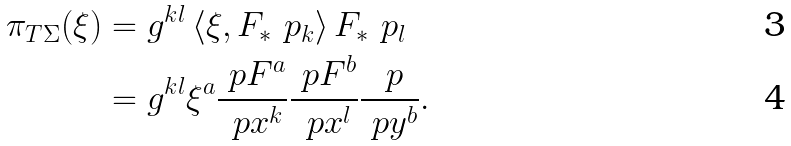<formula> <loc_0><loc_0><loc_500><loc_500>\pi _ { T \Sigma } ( \xi ) & = g ^ { k l } \left \langle \xi , F _ { * } \ p _ { k } \right \rangle F _ { * } \ p _ { l } \\ & = g ^ { k l } \xi ^ { a } \frac { \ p F ^ { a } } { \ p x ^ { k } } \frac { \ p F ^ { b } } { \ p x ^ { l } } \frac { \ p } { \ p y ^ { b } } .</formula> 